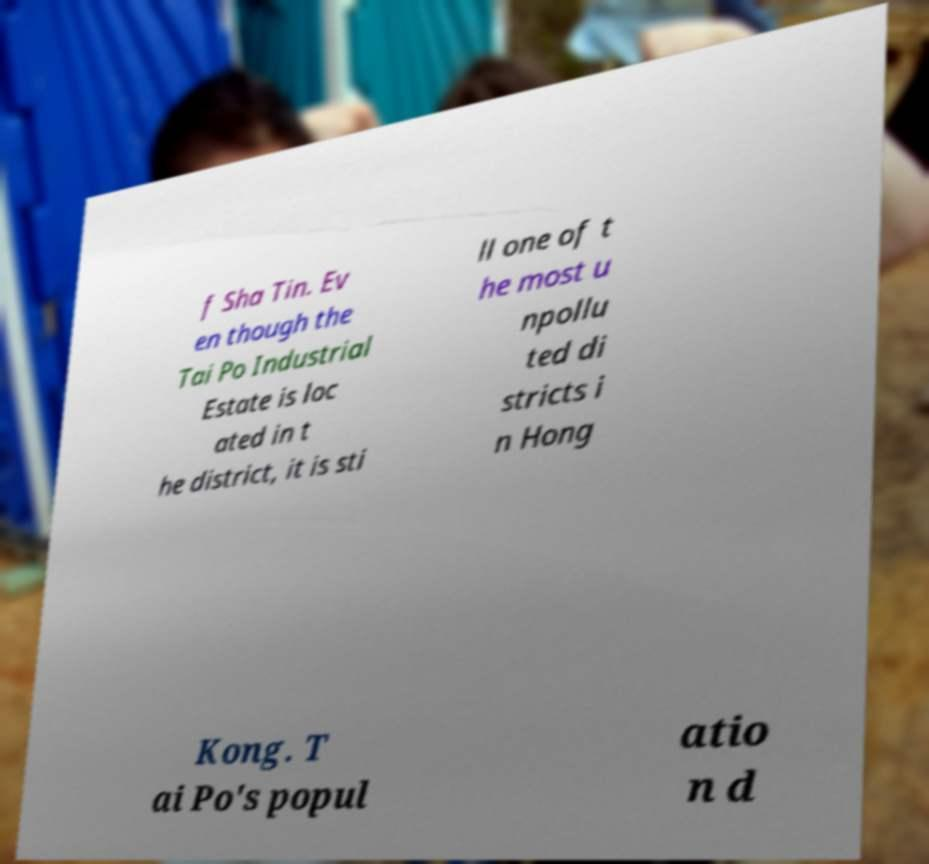Please identify and transcribe the text found in this image. f Sha Tin. Ev en though the Tai Po Industrial Estate is loc ated in t he district, it is sti ll one of t he most u npollu ted di stricts i n Hong Kong. T ai Po's popul atio n d 